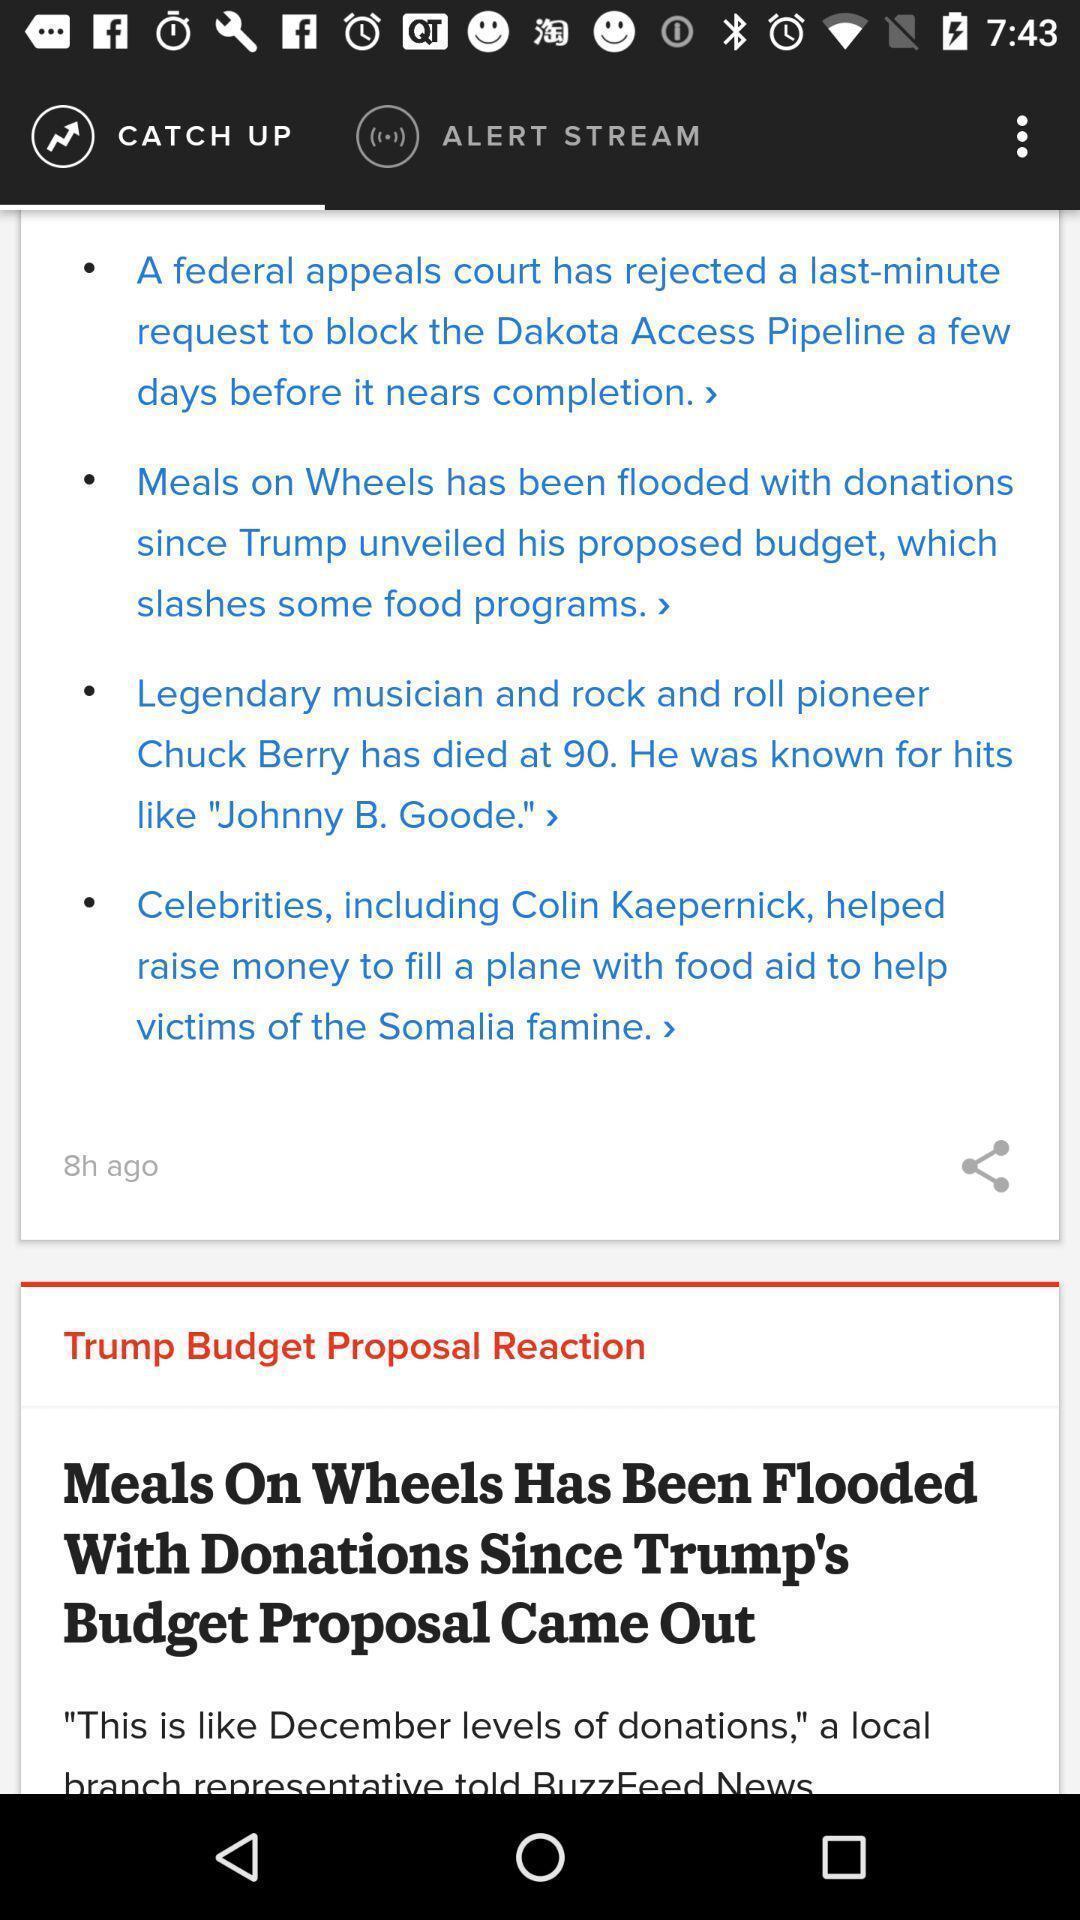Provide a detailed account of this screenshot. Screen displaying list of headlines. 